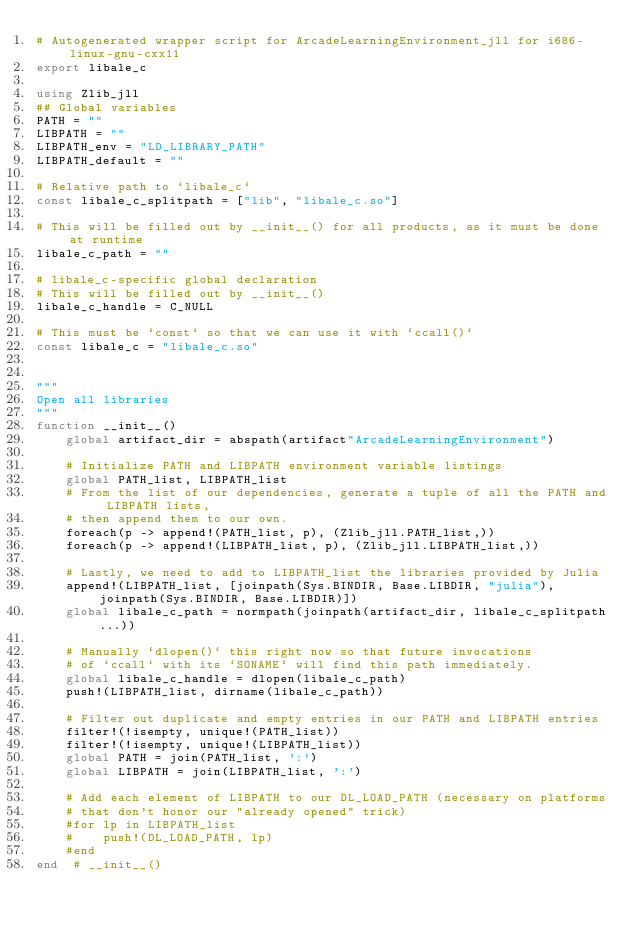Convert code to text. <code><loc_0><loc_0><loc_500><loc_500><_Julia_># Autogenerated wrapper script for ArcadeLearningEnvironment_jll for i686-linux-gnu-cxx11
export libale_c

using Zlib_jll
## Global variables
PATH = ""
LIBPATH = ""
LIBPATH_env = "LD_LIBRARY_PATH"
LIBPATH_default = ""

# Relative path to `libale_c`
const libale_c_splitpath = ["lib", "libale_c.so"]

# This will be filled out by __init__() for all products, as it must be done at runtime
libale_c_path = ""

# libale_c-specific global declaration
# This will be filled out by __init__()
libale_c_handle = C_NULL

# This must be `const` so that we can use it with `ccall()`
const libale_c = "libale_c.so"


"""
Open all libraries
"""
function __init__()
    global artifact_dir = abspath(artifact"ArcadeLearningEnvironment")

    # Initialize PATH and LIBPATH environment variable listings
    global PATH_list, LIBPATH_list
    # From the list of our dependencies, generate a tuple of all the PATH and LIBPATH lists,
    # then append them to our own.
    foreach(p -> append!(PATH_list, p), (Zlib_jll.PATH_list,))
    foreach(p -> append!(LIBPATH_list, p), (Zlib_jll.LIBPATH_list,))

    # Lastly, we need to add to LIBPATH_list the libraries provided by Julia
    append!(LIBPATH_list, [joinpath(Sys.BINDIR, Base.LIBDIR, "julia"), joinpath(Sys.BINDIR, Base.LIBDIR)])
    global libale_c_path = normpath(joinpath(artifact_dir, libale_c_splitpath...))

    # Manually `dlopen()` this right now so that future invocations
    # of `ccall` with its `SONAME` will find this path immediately.
    global libale_c_handle = dlopen(libale_c_path)
    push!(LIBPATH_list, dirname(libale_c_path))

    # Filter out duplicate and empty entries in our PATH and LIBPATH entries
    filter!(!isempty, unique!(PATH_list))
    filter!(!isempty, unique!(LIBPATH_list))
    global PATH = join(PATH_list, ':')
    global LIBPATH = join(LIBPATH_list, ':')

    # Add each element of LIBPATH to our DL_LOAD_PATH (necessary on platforms
    # that don't honor our "already opened" trick)
    #for lp in LIBPATH_list
    #    push!(DL_LOAD_PATH, lp)
    #end
end  # __init__()

</code> 